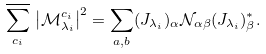<formula> <loc_0><loc_0><loc_500><loc_500>\overline { \sum _ { c _ { i } } } \, \left | \mathcal { M } _ { \lambda _ { i } } ^ { c _ { i } } \right | ^ { 2 } = \sum _ { a , b } ( J _ { \lambda _ { i } } ) _ { \alpha } { \mathcal { N } } _ { \alpha \beta } ( J _ { \lambda _ { i } } ) _ { \beta } ^ { * } .</formula> 